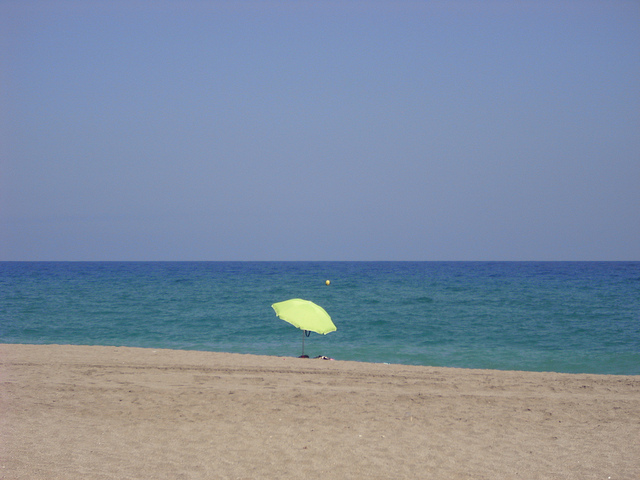<image>What is the object in the middle? I don't know what the object in the middle is. However, it might be an umbrella. What is the object in the middle? I am not sure what the object in the middle is. However, it seems to be an umbrella. 